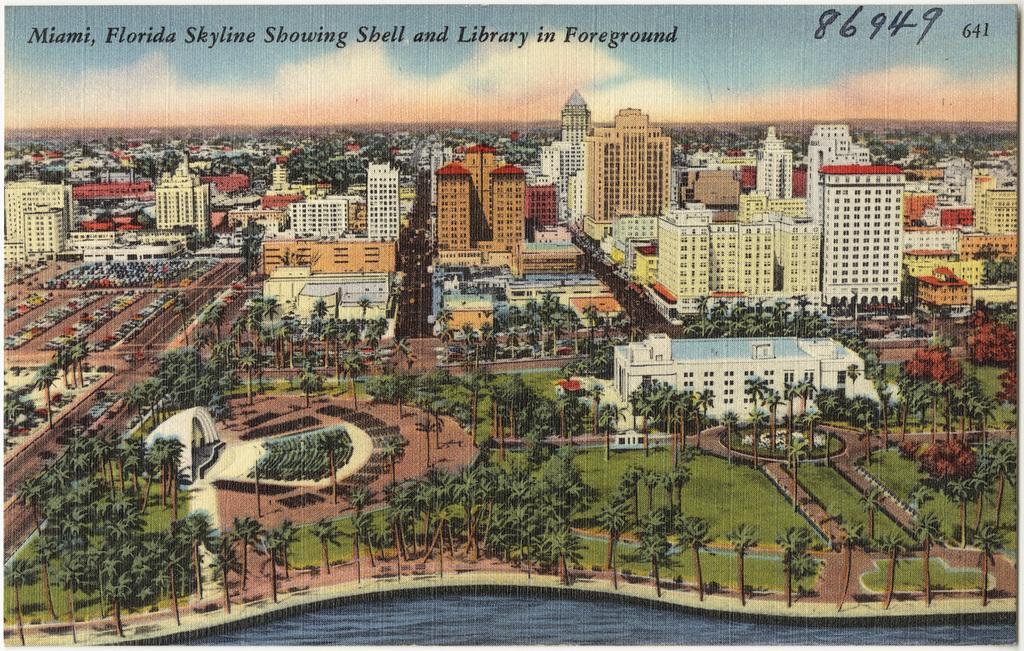How would you summarize this image in a sentence or two? This is a poster having image of water, trees, plants, buildings, vehicles and grass on the ground and there are clouds in the blue sky. On this poster, there are numbers and a text. 